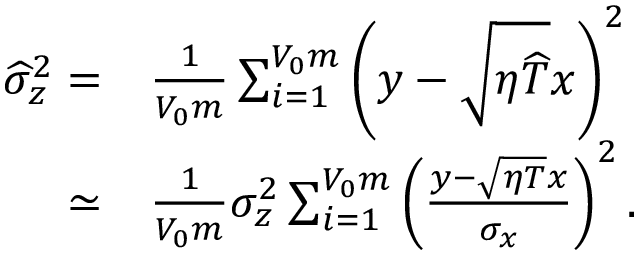<formula> <loc_0><loc_0><loc_500><loc_500>\begin{array} { r l } { \widehat { \sigma } _ { z } ^ { 2 } = } & \frac { 1 } { V _ { 0 } m } \sum _ { i = 1 } ^ { V _ { 0 } m } \left ( y - \sqrt { \eta \widehat { T } } x \right ) ^ { 2 } } \\ { \simeq } & \frac { 1 } { V _ { 0 } m } \sigma _ { z } ^ { 2 } \sum _ { i = 1 } ^ { V _ { 0 } m } \left ( \frac { y - \sqrt { \eta T } x } { \sigma _ { x } } \right ) ^ { 2 } . } \end{array}</formula> 